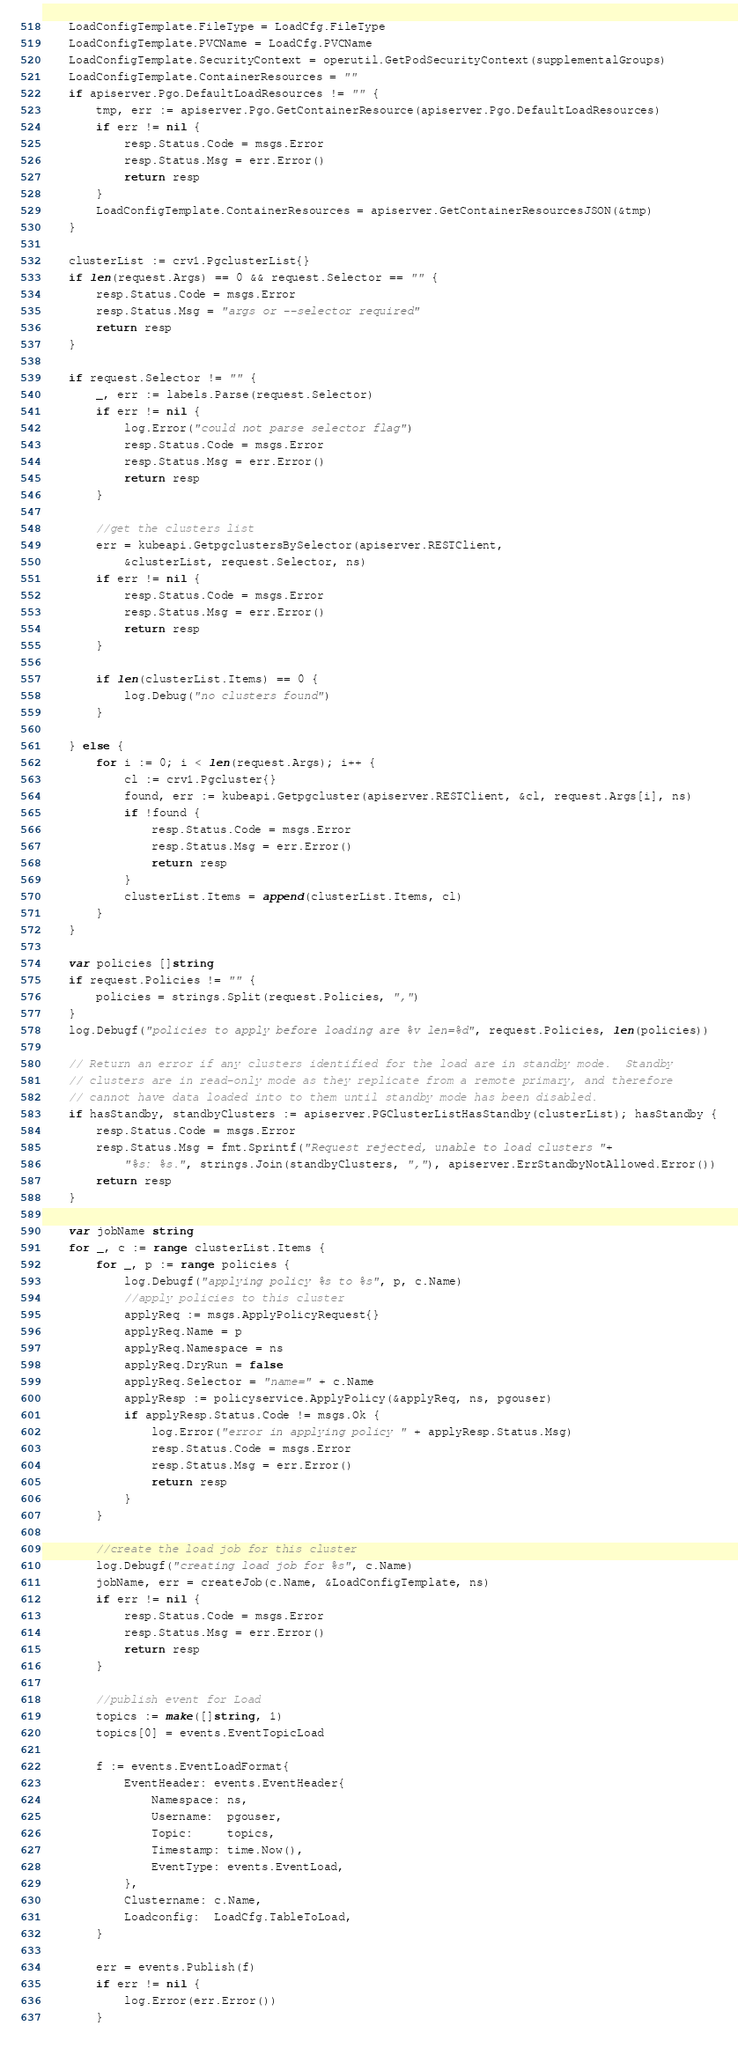Convert code to text. <code><loc_0><loc_0><loc_500><loc_500><_Go_>	LoadConfigTemplate.FileType = LoadCfg.FileType
	LoadConfigTemplate.PVCName = LoadCfg.PVCName
	LoadConfigTemplate.SecurityContext = operutil.GetPodSecurityContext(supplementalGroups)
	LoadConfigTemplate.ContainerResources = ""
	if apiserver.Pgo.DefaultLoadResources != "" {
		tmp, err := apiserver.Pgo.GetContainerResource(apiserver.Pgo.DefaultLoadResources)
		if err != nil {
			resp.Status.Code = msgs.Error
			resp.Status.Msg = err.Error()
			return resp
		}
		LoadConfigTemplate.ContainerResources = apiserver.GetContainerResourcesJSON(&tmp)
	}

	clusterList := crv1.PgclusterList{}
	if len(request.Args) == 0 && request.Selector == "" {
		resp.Status.Code = msgs.Error
		resp.Status.Msg = "args or --selector required"
		return resp
	}

	if request.Selector != "" {
		_, err := labels.Parse(request.Selector)
		if err != nil {
			log.Error("could not parse selector flag")
			resp.Status.Code = msgs.Error
			resp.Status.Msg = err.Error()
			return resp
		}

		//get the clusters list
		err = kubeapi.GetpgclustersBySelector(apiserver.RESTClient,
			&clusterList, request.Selector, ns)
		if err != nil {
			resp.Status.Code = msgs.Error
			resp.Status.Msg = err.Error()
			return resp
		}

		if len(clusterList.Items) == 0 {
			log.Debug("no clusters found")
		}

	} else {
		for i := 0; i < len(request.Args); i++ {
			cl := crv1.Pgcluster{}
			found, err := kubeapi.Getpgcluster(apiserver.RESTClient, &cl, request.Args[i], ns)
			if !found {
				resp.Status.Code = msgs.Error
				resp.Status.Msg = err.Error()
				return resp
			}
			clusterList.Items = append(clusterList.Items, cl)
		}
	}

	var policies []string
	if request.Policies != "" {
		policies = strings.Split(request.Policies, ",")
	}
	log.Debugf("policies to apply before loading are %v len=%d", request.Policies, len(policies))

	// Return an error if any clusters identified for the load are in standby mode.  Standby
	// clusters are in read-only mode as they replicate from a remote primary, and therefore
	// cannot have data loaded into to them until standby mode has been disabled.
	if hasStandby, standbyClusters := apiserver.PGClusterListHasStandby(clusterList); hasStandby {
		resp.Status.Code = msgs.Error
		resp.Status.Msg = fmt.Sprintf("Request rejected, unable to load clusters "+
			"%s: %s.", strings.Join(standbyClusters, ","), apiserver.ErrStandbyNotAllowed.Error())
		return resp
	}

	var jobName string
	for _, c := range clusterList.Items {
		for _, p := range policies {
			log.Debugf("applying policy %s to %s", p, c.Name)
			//apply policies to this cluster
			applyReq := msgs.ApplyPolicyRequest{}
			applyReq.Name = p
			applyReq.Namespace = ns
			applyReq.DryRun = false
			applyReq.Selector = "name=" + c.Name
			applyResp := policyservice.ApplyPolicy(&applyReq, ns, pgouser)
			if applyResp.Status.Code != msgs.Ok {
				log.Error("error in applying policy " + applyResp.Status.Msg)
				resp.Status.Code = msgs.Error
				resp.Status.Msg = err.Error()
				return resp
			}
		}

		//create the load job for this cluster
		log.Debugf("creating load job for %s", c.Name)
		jobName, err = createJob(c.Name, &LoadConfigTemplate, ns)
		if err != nil {
			resp.Status.Code = msgs.Error
			resp.Status.Msg = err.Error()
			return resp
		}

		//publish event for Load
		topics := make([]string, 1)
		topics[0] = events.EventTopicLoad

		f := events.EventLoadFormat{
			EventHeader: events.EventHeader{
				Namespace: ns,
				Username:  pgouser,
				Topic:     topics,
				Timestamp: time.Now(),
				EventType: events.EventLoad,
			},
			Clustername: c.Name,
			Loadconfig:  LoadCfg.TableToLoad,
		}

		err = events.Publish(f)
		if err != nil {
			log.Error(err.Error())
		}
</code> 